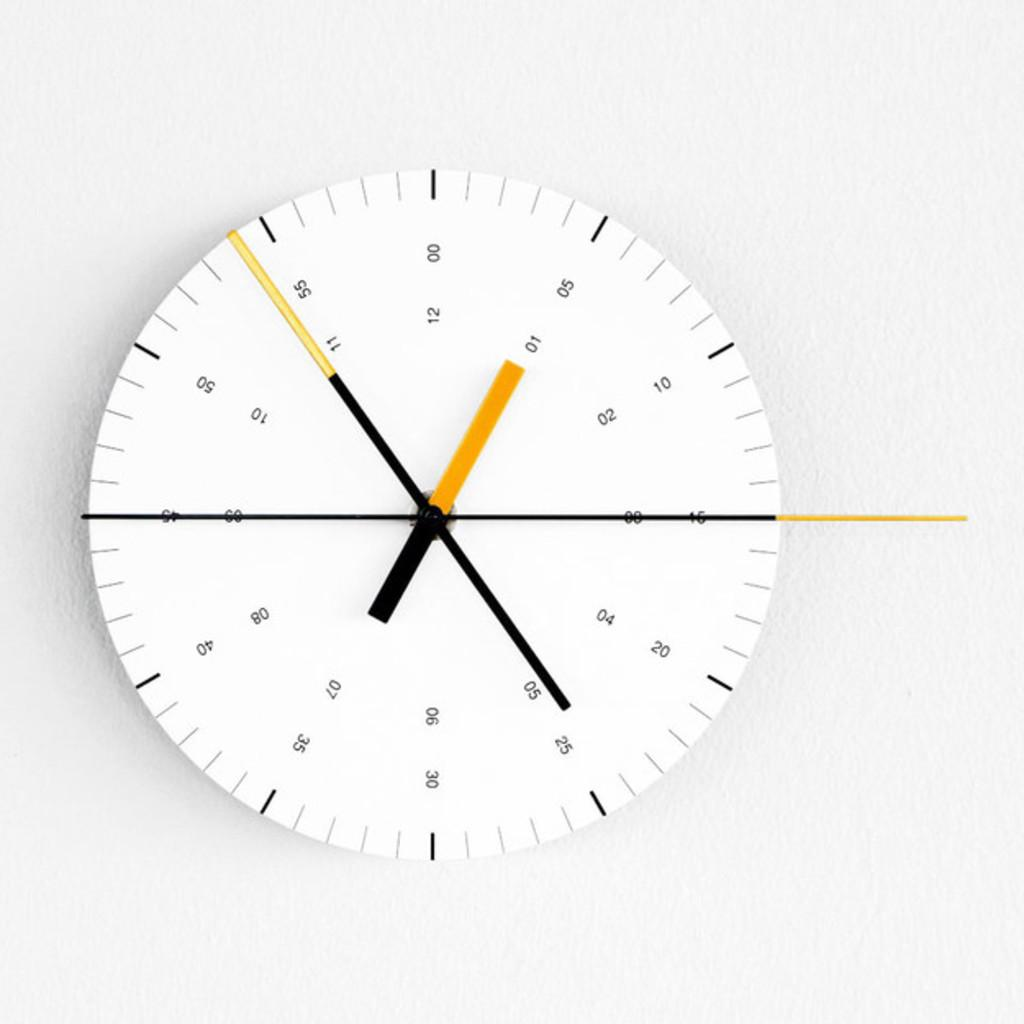<image>
Write a terse but informative summary of the picture. The small yellow hand on the clock points to 01 05. 